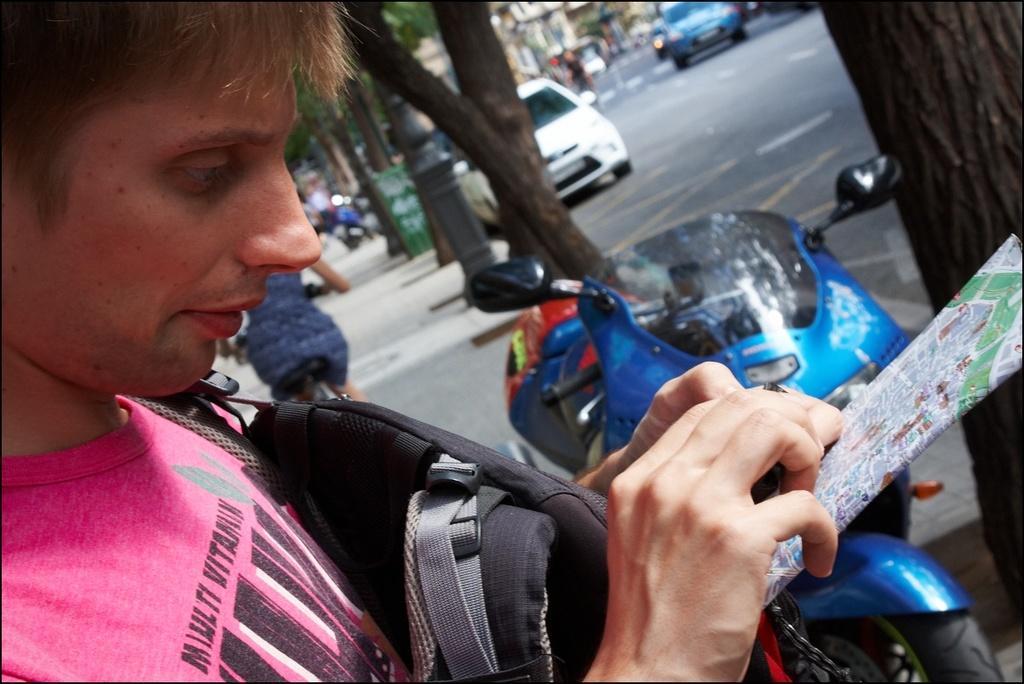Describe this image in one or two sentences. This is the picture of a place where we have a person who is holding the backpack, phone and to the side there is an other person on the bicycle and also we can see some cars, trees and some other things around. 